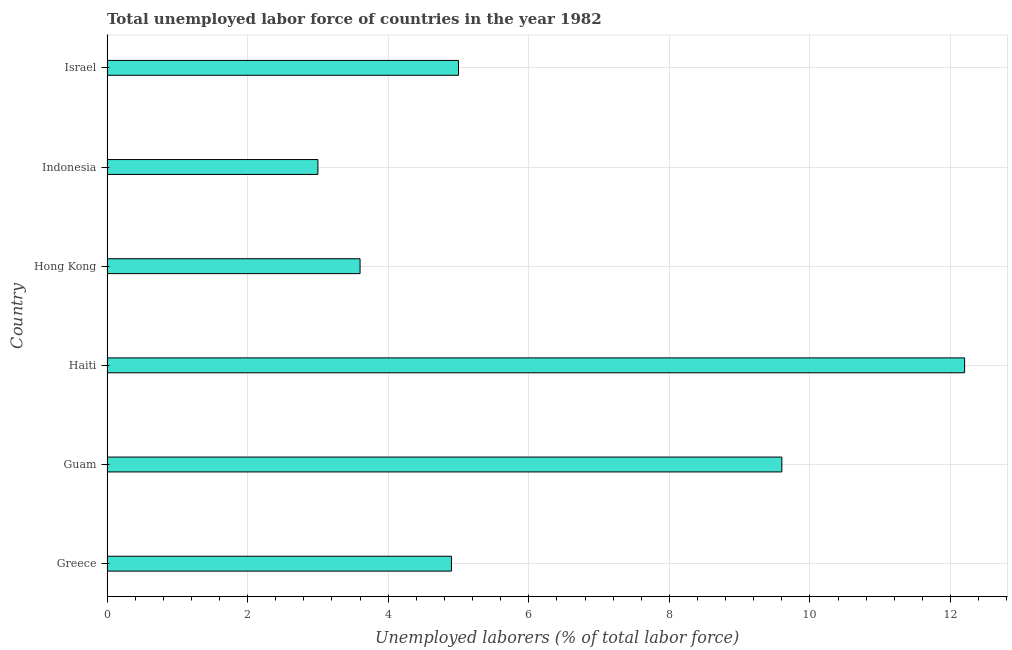Does the graph contain any zero values?
Provide a short and direct response. No. Does the graph contain grids?
Provide a succinct answer. Yes. What is the title of the graph?
Your response must be concise. Total unemployed labor force of countries in the year 1982. What is the label or title of the X-axis?
Ensure brevity in your answer.  Unemployed laborers (% of total labor force). What is the label or title of the Y-axis?
Make the answer very short. Country. What is the total unemployed labour force in Greece?
Offer a terse response. 4.9. Across all countries, what is the maximum total unemployed labour force?
Give a very brief answer. 12.2. In which country was the total unemployed labour force maximum?
Keep it short and to the point. Haiti. What is the sum of the total unemployed labour force?
Offer a very short reply. 38.3. What is the average total unemployed labour force per country?
Offer a terse response. 6.38. What is the median total unemployed labour force?
Your answer should be very brief. 4.95. Is the difference between the total unemployed labour force in Guam and Hong Kong greater than the difference between any two countries?
Make the answer very short. No. How many bars are there?
Offer a very short reply. 6. How many countries are there in the graph?
Provide a succinct answer. 6. What is the difference between two consecutive major ticks on the X-axis?
Your response must be concise. 2. Are the values on the major ticks of X-axis written in scientific E-notation?
Offer a terse response. No. What is the Unemployed laborers (% of total labor force) in Greece?
Your answer should be compact. 4.9. What is the Unemployed laborers (% of total labor force) of Guam?
Your answer should be very brief. 9.6. What is the Unemployed laborers (% of total labor force) in Haiti?
Provide a short and direct response. 12.2. What is the Unemployed laborers (% of total labor force) in Hong Kong?
Make the answer very short. 3.6. What is the difference between the Unemployed laborers (% of total labor force) in Greece and Hong Kong?
Your answer should be very brief. 1.3. What is the difference between the Unemployed laborers (% of total labor force) in Haiti and Hong Kong?
Keep it short and to the point. 8.6. What is the difference between the Unemployed laborers (% of total labor force) in Hong Kong and Indonesia?
Make the answer very short. 0.6. What is the difference between the Unemployed laborers (% of total labor force) in Hong Kong and Israel?
Give a very brief answer. -1.4. What is the ratio of the Unemployed laborers (% of total labor force) in Greece to that in Guam?
Your answer should be very brief. 0.51. What is the ratio of the Unemployed laborers (% of total labor force) in Greece to that in Haiti?
Offer a very short reply. 0.4. What is the ratio of the Unemployed laborers (% of total labor force) in Greece to that in Hong Kong?
Your answer should be very brief. 1.36. What is the ratio of the Unemployed laborers (% of total labor force) in Greece to that in Indonesia?
Offer a terse response. 1.63. What is the ratio of the Unemployed laborers (% of total labor force) in Greece to that in Israel?
Ensure brevity in your answer.  0.98. What is the ratio of the Unemployed laborers (% of total labor force) in Guam to that in Haiti?
Your response must be concise. 0.79. What is the ratio of the Unemployed laborers (% of total labor force) in Guam to that in Hong Kong?
Ensure brevity in your answer.  2.67. What is the ratio of the Unemployed laborers (% of total labor force) in Guam to that in Indonesia?
Provide a short and direct response. 3.2. What is the ratio of the Unemployed laborers (% of total labor force) in Guam to that in Israel?
Ensure brevity in your answer.  1.92. What is the ratio of the Unemployed laborers (% of total labor force) in Haiti to that in Hong Kong?
Provide a short and direct response. 3.39. What is the ratio of the Unemployed laborers (% of total labor force) in Haiti to that in Indonesia?
Provide a succinct answer. 4.07. What is the ratio of the Unemployed laborers (% of total labor force) in Haiti to that in Israel?
Your answer should be very brief. 2.44. What is the ratio of the Unemployed laborers (% of total labor force) in Hong Kong to that in Israel?
Provide a succinct answer. 0.72. 